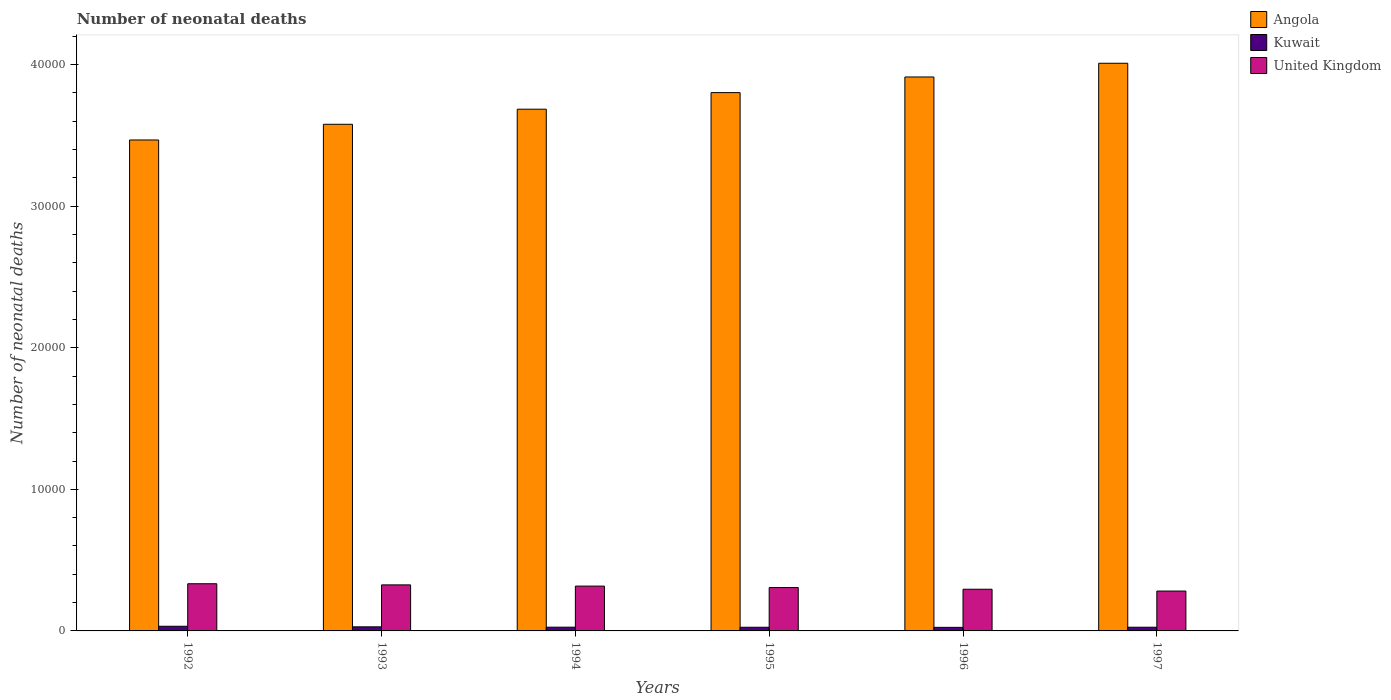How many different coloured bars are there?
Offer a very short reply. 3. How many groups of bars are there?
Keep it short and to the point. 6. How many bars are there on the 1st tick from the left?
Offer a terse response. 3. What is the label of the 4th group of bars from the left?
Offer a terse response. 1995. In how many cases, is the number of bars for a given year not equal to the number of legend labels?
Your response must be concise. 0. What is the number of neonatal deaths in in Angola in 1993?
Keep it short and to the point. 3.58e+04. Across all years, what is the maximum number of neonatal deaths in in Kuwait?
Offer a terse response. 329. Across all years, what is the minimum number of neonatal deaths in in Kuwait?
Offer a terse response. 252. In which year was the number of neonatal deaths in in United Kingdom maximum?
Your answer should be very brief. 1992. What is the total number of neonatal deaths in in Kuwait in the graph?
Your answer should be compact. 1653. What is the difference between the number of neonatal deaths in in Kuwait in 1992 and that in 1996?
Give a very brief answer. 77. What is the difference between the number of neonatal deaths in in United Kingdom in 1992 and the number of neonatal deaths in in Angola in 1993?
Keep it short and to the point. -3.24e+04. What is the average number of neonatal deaths in in Angola per year?
Keep it short and to the point. 3.74e+04. In the year 1993, what is the difference between the number of neonatal deaths in in Kuwait and number of neonatal deaths in in United Kingdom?
Your response must be concise. -2964. In how many years, is the number of neonatal deaths in in Angola greater than 6000?
Your answer should be very brief. 6. What is the ratio of the number of neonatal deaths in in Kuwait in 1995 to that in 1997?
Give a very brief answer. 0.99. What is the difference between the highest and the lowest number of neonatal deaths in in Kuwait?
Your response must be concise. 77. In how many years, is the number of neonatal deaths in in Angola greater than the average number of neonatal deaths in in Angola taken over all years?
Give a very brief answer. 3. Is the sum of the number of neonatal deaths in in Angola in 1994 and 1997 greater than the maximum number of neonatal deaths in in United Kingdom across all years?
Provide a succinct answer. Yes. What does the 2nd bar from the right in 1997 represents?
Your response must be concise. Kuwait. How many bars are there?
Make the answer very short. 18. Are all the bars in the graph horizontal?
Provide a short and direct response. No. How many years are there in the graph?
Provide a succinct answer. 6. What is the difference between two consecutive major ticks on the Y-axis?
Make the answer very short. 10000. Are the values on the major ticks of Y-axis written in scientific E-notation?
Make the answer very short. No. Does the graph contain grids?
Ensure brevity in your answer.  No. Where does the legend appear in the graph?
Make the answer very short. Top right. How are the legend labels stacked?
Keep it short and to the point. Vertical. What is the title of the graph?
Give a very brief answer. Number of neonatal deaths. Does "Togo" appear as one of the legend labels in the graph?
Provide a short and direct response. No. What is the label or title of the Y-axis?
Provide a short and direct response. Number of neonatal deaths. What is the Number of neonatal deaths of Angola in 1992?
Ensure brevity in your answer.  3.47e+04. What is the Number of neonatal deaths of Kuwait in 1992?
Your answer should be compact. 329. What is the Number of neonatal deaths in United Kingdom in 1992?
Your response must be concise. 3332. What is the Number of neonatal deaths of Angola in 1993?
Your response must be concise. 3.58e+04. What is the Number of neonatal deaths in Kuwait in 1993?
Make the answer very short. 288. What is the Number of neonatal deaths of United Kingdom in 1993?
Your answer should be very brief. 3252. What is the Number of neonatal deaths of Angola in 1994?
Give a very brief answer. 3.68e+04. What is the Number of neonatal deaths of Kuwait in 1994?
Your answer should be compact. 264. What is the Number of neonatal deaths in United Kingdom in 1994?
Offer a terse response. 3165. What is the Number of neonatal deaths in Angola in 1995?
Give a very brief answer. 3.80e+04. What is the Number of neonatal deaths of Kuwait in 1995?
Make the answer very short. 259. What is the Number of neonatal deaths of United Kingdom in 1995?
Your answer should be compact. 3063. What is the Number of neonatal deaths of Angola in 1996?
Your response must be concise. 3.91e+04. What is the Number of neonatal deaths in Kuwait in 1996?
Provide a succinct answer. 252. What is the Number of neonatal deaths in United Kingdom in 1996?
Ensure brevity in your answer.  2944. What is the Number of neonatal deaths of Angola in 1997?
Give a very brief answer. 4.01e+04. What is the Number of neonatal deaths in Kuwait in 1997?
Offer a very short reply. 261. What is the Number of neonatal deaths in United Kingdom in 1997?
Make the answer very short. 2816. Across all years, what is the maximum Number of neonatal deaths in Angola?
Your answer should be very brief. 4.01e+04. Across all years, what is the maximum Number of neonatal deaths in Kuwait?
Provide a succinct answer. 329. Across all years, what is the maximum Number of neonatal deaths of United Kingdom?
Your answer should be very brief. 3332. Across all years, what is the minimum Number of neonatal deaths in Angola?
Ensure brevity in your answer.  3.47e+04. Across all years, what is the minimum Number of neonatal deaths in Kuwait?
Offer a very short reply. 252. Across all years, what is the minimum Number of neonatal deaths of United Kingdom?
Keep it short and to the point. 2816. What is the total Number of neonatal deaths of Angola in the graph?
Provide a short and direct response. 2.25e+05. What is the total Number of neonatal deaths of Kuwait in the graph?
Make the answer very short. 1653. What is the total Number of neonatal deaths in United Kingdom in the graph?
Your answer should be very brief. 1.86e+04. What is the difference between the Number of neonatal deaths of Angola in 1992 and that in 1993?
Make the answer very short. -1108. What is the difference between the Number of neonatal deaths of Kuwait in 1992 and that in 1993?
Your response must be concise. 41. What is the difference between the Number of neonatal deaths of Angola in 1992 and that in 1994?
Offer a very short reply. -2175. What is the difference between the Number of neonatal deaths in United Kingdom in 1992 and that in 1994?
Keep it short and to the point. 167. What is the difference between the Number of neonatal deaths of Angola in 1992 and that in 1995?
Your answer should be very brief. -3345. What is the difference between the Number of neonatal deaths in Kuwait in 1992 and that in 1995?
Ensure brevity in your answer.  70. What is the difference between the Number of neonatal deaths of United Kingdom in 1992 and that in 1995?
Provide a short and direct response. 269. What is the difference between the Number of neonatal deaths of Angola in 1992 and that in 1996?
Your answer should be compact. -4450. What is the difference between the Number of neonatal deaths of United Kingdom in 1992 and that in 1996?
Offer a terse response. 388. What is the difference between the Number of neonatal deaths in Angola in 1992 and that in 1997?
Your answer should be compact. -5419. What is the difference between the Number of neonatal deaths in United Kingdom in 1992 and that in 1997?
Your response must be concise. 516. What is the difference between the Number of neonatal deaths of Angola in 1993 and that in 1994?
Offer a terse response. -1067. What is the difference between the Number of neonatal deaths of Kuwait in 1993 and that in 1994?
Give a very brief answer. 24. What is the difference between the Number of neonatal deaths in Angola in 1993 and that in 1995?
Make the answer very short. -2237. What is the difference between the Number of neonatal deaths of United Kingdom in 1993 and that in 1995?
Give a very brief answer. 189. What is the difference between the Number of neonatal deaths of Angola in 1993 and that in 1996?
Offer a very short reply. -3342. What is the difference between the Number of neonatal deaths in Kuwait in 1993 and that in 1996?
Ensure brevity in your answer.  36. What is the difference between the Number of neonatal deaths in United Kingdom in 1993 and that in 1996?
Offer a terse response. 308. What is the difference between the Number of neonatal deaths of Angola in 1993 and that in 1997?
Make the answer very short. -4311. What is the difference between the Number of neonatal deaths in Kuwait in 1993 and that in 1997?
Ensure brevity in your answer.  27. What is the difference between the Number of neonatal deaths in United Kingdom in 1993 and that in 1997?
Ensure brevity in your answer.  436. What is the difference between the Number of neonatal deaths in Angola in 1994 and that in 1995?
Give a very brief answer. -1170. What is the difference between the Number of neonatal deaths in United Kingdom in 1994 and that in 1995?
Offer a terse response. 102. What is the difference between the Number of neonatal deaths in Angola in 1994 and that in 1996?
Your response must be concise. -2275. What is the difference between the Number of neonatal deaths of United Kingdom in 1994 and that in 1996?
Provide a succinct answer. 221. What is the difference between the Number of neonatal deaths of Angola in 1994 and that in 1997?
Give a very brief answer. -3244. What is the difference between the Number of neonatal deaths of United Kingdom in 1994 and that in 1997?
Ensure brevity in your answer.  349. What is the difference between the Number of neonatal deaths in Angola in 1995 and that in 1996?
Offer a very short reply. -1105. What is the difference between the Number of neonatal deaths of Kuwait in 1995 and that in 1996?
Give a very brief answer. 7. What is the difference between the Number of neonatal deaths of United Kingdom in 1995 and that in 1996?
Ensure brevity in your answer.  119. What is the difference between the Number of neonatal deaths of Angola in 1995 and that in 1997?
Your response must be concise. -2074. What is the difference between the Number of neonatal deaths of United Kingdom in 1995 and that in 1997?
Your response must be concise. 247. What is the difference between the Number of neonatal deaths of Angola in 1996 and that in 1997?
Provide a succinct answer. -969. What is the difference between the Number of neonatal deaths in Kuwait in 1996 and that in 1997?
Ensure brevity in your answer.  -9. What is the difference between the Number of neonatal deaths in United Kingdom in 1996 and that in 1997?
Make the answer very short. 128. What is the difference between the Number of neonatal deaths in Angola in 1992 and the Number of neonatal deaths in Kuwait in 1993?
Your answer should be compact. 3.44e+04. What is the difference between the Number of neonatal deaths of Angola in 1992 and the Number of neonatal deaths of United Kingdom in 1993?
Your answer should be compact. 3.14e+04. What is the difference between the Number of neonatal deaths of Kuwait in 1992 and the Number of neonatal deaths of United Kingdom in 1993?
Provide a short and direct response. -2923. What is the difference between the Number of neonatal deaths of Angola in 1992 and the Number of neonatal deaths of Kuwait in 1994?
Provide a succinct answer. 3.44e+04. What is the difference between the Number of neonatal deaths of Angola in 1992 and the Number of neonatal deaths of United Kingdom in 1994?
Provide a short and direct response. 3.15e+04. What is the difference between the Number of neonatal deaths of Kuwait in 1992 and the Number of neonatal deaths of United Kingdom in 1994?
Your answer should be compact. -2836. What is the difference between the Number of neonatal deaths of Angola in 1992 and the Number of neonatal deaths of Kuwait in 1995?
Provide a succinct answer. 3.44e+04. What is the difference between the Number of neonatal deaths in Angola in 1992 and the Number of neonatal deaths in United Kingdom in 1995?
Ensure brevity in your answer.  3.16e+04. What is the difference between the Number of neonatal deaths in Kuwait in 1992 and the Number of neonatal deaths in United Kingdom in 1995?
Provide a succinct answer. -2734. What is the difference between the Number of neonatal deaths of Angola in 1992 and the Number of neonatal deaths of Kuwait in 1996?
Offer a terse response. 3.44e+04. What is the difference between the Number of neonatal deaths in Angola in 1992 and the Number of neonatal deaths in United Kingdom in 1996?
Your response must be concise. 3.17e+04. What is the difference between the Number of neonatal deaths of Kuwait in 1992 and the Number of neonatal deaths of United Kingdom in 1996?
Offer a very short reply. -2615. What is the difference between the Number of neonatal deaths of Angola in 1992 and the Number of neonatal deaths of Kuwait in 1997?
Offer a terse response. 3.44e+04. What is the difference between the Number of neonatal deaths in Angola in 1992 and the Number of neonatal deaths in United Kingdom in 1997?
Keep it short and to the point. 3.19e+04. What is the difference between the Number of neonatal deaths in Kuwait in 1992 and the Number of neonatal deaths in United Kingdom in 1997?
Give a very brief answer. -2487. What is the difference between the Number of neonatal deaths of Angola in 1993 and the Number of neonatal deaths of Kuwait in 1994?
Offer a terse response. 3.55e+04. What is the difference between the Number of neonatal deaths in Angola in 1993 and the Number of neonatal deaths in United Kingdom in 1994?
Provide a short and direct response. 3.26e+04. What is the difference between the Number of neonatal deaths in Kuwait in 1993 and the Number of neonatal deaths in United Kingdom in 1994?
Give a very brief answer. -2877. What is the difference between the Number of neonatal deaths in Angola in 1993 and the Number of neonatal deaths in Kuwait in 1995?
Ensure brevity in your answer.  3.55e+04. What is the difference between the Number of neonatal deaths of Angola in 1993 and the Number of neonatal deaths of United Kingdom in 1995?
Offer a very short reply. 3.27e+04. What is the difference between the Number of neonatal deaths of Kuwait in 1993 and the Number of neonatal deaths of United Kingdom in 1995?
Your answer should be compact. -2775. What is the difference between the Number of neonatal deaths in Angola in 1993 and the Number of neonatal deaths in Kuwait in 1996?
Give a very brief answer. 3.55e+04. What is the difference between the Number of neonatal deaths of Angola in 1993 and the Number of neonatal deaths of United Kingdom in 1996?
Your answer should be very brief. 3.28e+04. What is the difference between the Number of neonatal deaths of Kuwait in 1993 and the Number of neonatal deaths of United Kingdom in 1996?
Your response must be concise. -2656. What is the difference between the Number of neonatal deaths of Angola in 1993 and the Number of neonatal deaths of Kuwait in 1997?
Your answer should be compact. 3.55e+04. What is the difference between the Number of neonatal deaths in Angola in 1993 and the Number of neonatal deaths in United Kingdom in 1997?
Offer a terse response. 3.30e+04. What is the difference between the Number of neonatal deaths of Kuwait in 1993 and the Number of neonatal deaths of United Kingdom in 1997?
Your response must be concise. -2528. What is the difference between the Number of neonatal deaths in Angola in 1994 and the Number of neonatal deaths in Kuwait in 1995?
Your answer should be very brief. 3.66e+04. What is the difference between the Number of neonatal deaths in Angola in 1994 and the Number of neonatal deaths in United Kingdom in 1995?
Keep it short and to the point. 3.38e+04. What is the difference between the Number of neonatal deaths in Kuwait in 1994 and the Number of neonatal deaths in United Kingdom in 1995?
Provide a succinct answer. -2799. What is the difference between the Number of neonatal deaths of Angola in 1994 and the Number of neonatal deaths of Kuwait in 1996?
Provide a short and direct response. 3.66e+04. What is the difference between the Number of neonatal deaths in Angola in 1994 and the Number of neonatal deaths in United Kingdom in 1996?
Ensure brevity in your answer.  3.39e+04. What is the difference between the Number of neonatal deaths of Kuwait in 1994 and the Number of neonatal deaths of United Kingdom in 1996?
Ensure brevity in your answer.  -2680. What is the difference between the Number of neonatal deaths of Angola in 1994 and the Number of neonatal deaths of Kuwait in 1997?
Your answer should be very brief. 3.66e+04. What is the difference between the Number of neonatal deaths of Angola in 1994 and the Number of neonatal deaths of United Kingdom in 1997?
Offer a terse response. 3.40e+04. What is the difference between the Number of neonatal deaths in Kuwait in 1994 and the Number of neonatal deaths in United Kingdom in 1997?
Provide a succinct answer. -2552. What is the difference between the Number of neonatal deaths of Angola in 1995 and the Number of neonatal deaths of Kuwait in 1996?
Your answer should be compact. 3.78e+04. What is the difference between the Number of neonatal deaths in Angola in 1995 and the Number of neonatal deaths in United Kingdom in 1996?
Give a very brief answer. 3.51e+04. What is the difference between the Number of neonatal deaths in Kuwait in 1995 and the Number of neonatal deaths in United Kingdom in 1996?
Offer a terse response. -2685. What is the difference between the Number of neonatal deaths in Angola in 1995 and the Number of neonatal deaths in Kuwait in 1997?
Provide a short and direct response. 3.78e+04. What is the difference between the Number of neonatal deaths in Angola in 1995 and the Number of neonatal deaths in United Kingdom in 1997?
Provide a short and direct response. 3.52e+04. What is the difference between the Number of neonatal deaths of Kuwait in 1995 and the Number of neonatal deaths of United Kingdom in 1997?
Your response must be concise. -2557. What is the difference between the Number of neonatal deaths of Angola in 1996 and the Number of neonatal deaths of Kuwait in 1997?
Your answer should be very brief. 3.89e+04. What is the difference between the Number of neonatal deaths of Angola in 1996 and the Number of neonatal deaths of United Kingdom in 1997?
Provide a short and direct response. 3.63e+04. What is the difference between the Number of neonatal deaths in Kuwait in 1996 and the Number of neonatal deaths in United Kingdom in 1997?
Keep it short and to the point. -2564. What is the average Number of neonatal deaths in Angola per year?
Give a very brief answer. 3.74e+04. What is the average Number of neonatal deaths in Kuwait per year?
Offer a very short reply. 275.5. What is the average Number of neonatal deaths in United Kingdom per year?
Your answer should be very brief. 3095.33. In the year 1992, what is the difference between the Number of neonatal deaths of Angola and Number of neonatal deaths of Kuwait?
Keep it short and to the point. 3.43e+04. In the year 1992, what is the difference between the Number of neonatal deaths in Angola and Number of neonatal deaths in United Kingdom?
Your answer should be compact. 3.13e+04. In the year 1992, what is the difference between the Number of neonatal deaths of Kuwait and Number of neonatal deaths of United Kingdom?
Your response must be concise. -3003. In the year 1993, what is the difference between the Number of neonatal deaths in Angola and Number of neonatal deaths in Kuwait?
Offer a very short reply. 3.55e+04. In the year 1993, what is the difference between the Number of neonatal deaths of Angola and Number of neonatal deaths of United Kingdom?
Provide a short and direct response. 3.25e+04. In the year 1993, what is the difference between the Number of neonatal deaths of Kuwait and Number of neonatal deaths of United Kingdom?
Keep it short and to the point. -2964. In the year 1994, what is the difference between the Number of neonatal deaths in Angola and Number of neonatal deaths in Kuwait?
Make the answer very short. 3.66e+04. In the year 1994, what is the difference between the Number of neonatal deaths in Angola and Number of neonatal deaths in United Kingdom?
Your answer should be compact. 3.37e+04. In the year 1994, what is the difference between the Number of neonatal deaths in Kuwait and Number of neonatal deaths in United Kingdom?
Provide a succinct answer. -2901. In the year 1995, what is the difference between the Number of neonatal deaths in Angola and Number of neonatal deaths in Kuwait?
Provide a short and direct response. 3.78e+04. In the year 1995, what is the difference between the Number of neonatal deaths of Angola and Number of neonatal deaths of United Kingdom?
Provide a short and direct response. 3.50e+04. In the year 1995, what is the difference between the Number of neonatal deaths of Kuwait and Number of neonatal deaths of United Kingdom?
Ensure brevity in your answer.  -2804. In the year 1996, what is the difference between the Number of neonatal deaths in Angola and Number of neonatal deaths in Kuwait?
Offer a terse response. 3.89e+04. In the year 1996, what is the difference between the Number of neonatal deaths in Angola and Number of neonatal deaths in United Kingdom?
Give a very brief answer. 3.62e+04. In the year 1996, what is the difference between the Number of neonatal deaths of Kuwait and Number of neonatal deaths of United Kingdom?
Offer a terse response. -2692. In the year 1997, what is the difference between the Number of neonatal deaths in Angola and Number of neonatal deaths in Kuwait?
Offer a very short reply. 3.98e+04. In the year 1997, what is the difference between the Number of neonatal deaths of Angola and Number of neonatal deaths of United Kingdom?
Offer a terse response. 3.73e+04. In the year 1997, what is the difference between the Number of neonatal deaths in Kuwait and Number of neonatal deaths in United Kingdom?
Keep it short and to the point. -2555. What is the ratio of the Number of neonatal deaths in Angola in 1992 to that in 1993?
Your answer should be very brief. 0.97. What is the ratio of the Number of neonatal deaths of Kuwait in 1992 to that in 1993?
Offer a terse response. 1.14. What is the ratio of the Number of neonatal deaths in United Kingdom in 1992 to that in 1993?
Offer a very short reply. 1.02. What is the ratio of the Number of neonatal deaths of Angola in 1992 to that in 1994?
Offer a terse response. 0.94. What is the ratio of the Number of neonatal deaths of Kuwait in 1992 to that in 1994?
Give a very brief answer. 1.25. What is the ratio of the Number of neonatal deaths of United Kingdom in 1992 to that in 1994?
Make the answer very short. 1.05. What is the ratio of the Number of neonatal deaths in Angola in 1992 to that in 1995?
Your answer should be compact. 0.91. What is the ratio of the Number of neonatal deaths in Kuwait in 1992 to that in 1995?
Make the answer very short. 1.27. What is the ratio of the Number of neonatal deaths of United Kingdom in 1992 to that in 1995?
Your answer should be compact. 1.09. What is the ratio of the Number of neonatal deaths of Angola in 1992 to that in 1996?
Offer a very short reply. 0.89. What is the ratio of the Number of neonatal deaths of Kuwait in 1992 to that in 1996?
Give a very brief answer. 1.31. What is the ratio of the Number of neonatal deaths of United Kingdom in 1992 to that in 1996?
Ensure brevity in your answer.  1.13. What is the ratio of the Number of neonatal deaths of Angola in 1992 to that in 1997?
Your response must be concise. 0.86. What is the ratio of the Number of neonatal deaths in Kuwait in 1992 to that in 1997?
Make the answer very short. 1.26. What is the ratio of the Number of neonatal deaths in United Kingdom in 1992 to that in 1997?
Ensure brevity in your answer.  1.18. What is the ratio of the Number of neonatal deaths in Angola in 1993 to that in 1994?
Your answer should be compact. 0.97. What is the ratio of the Number of neonatal deaths in Kuwait in 1993 to that in 1994?
Give a very brief answer. 1.09. What is the ratio of the Number of neonatal deaths in United Kingdom in 1993 to that in 1994?
Provide a short and direct response. 1.03. What is the ratio of the Number of neonatal deaths in Angola in 1993 to that in 1995?
Offer a terse response. 0.94. What is the ratio of the Number of neonatal deaths of Kuwait in 1993 to that in 1995?
Your response must be concise. 1.11. What is the ratio of the Number of neonatal deaths in United Kingdom in 1993 to that in 1995?
Your answer should be very brief. 1.06. What is the ratio of the Number of neonatal deaths of Angola in 1993 to that in 1996?
Your answer should be very brief. 0.91. What is the ratio of the Number of neonatal deaths of Kuwait in 1993 to that in 1996?
Offer a terse response. 1.14. What is the ratio of the Number of neonatal deaths of United Kingdom in 1993 to that in 1996?
Give a very brief answer. 1.1. What is the ratio of the Number of neonatal deaths of Angola in 1993 to that in 1997?
Keep it short and to the point. 0.89. What is the ratio of the Number of neonatal deaths in Kuwait in 1993 to that in 1997?
Your answer should be compact. 1.1. What is the ratio of the Number of neonatal deaths in United Kingdom in 1993 to that in 1997?
Ensure brevity in your answer.  1.15. What is the ratio of the Number of neonatal deaths in Angola in 1994 to that in 1995?
Provide a short and direct response. 0.97. What is the ratio of the Number of neonatal deaths of Kuwait in 1994 to that in 1995?
Keep it short and to the point. 1.02. What is the ratio of the Number of neonatal deaths in United Kingdom in 1994 to that in 1995?
Give a very brief answer. 1.03. What is the ratio of the Number of neonatal deaths of Angola in 1994 to that in 1996?
Offer a very short reply. 0.94. What is the ratio of the Number of neonatal deaths in Kuwait in 1994 to that in 1996?
Provide a succinct answer. 1.05. What is the ratio of the Number of neonatal deaths of United Kingdom in 1994 to that in 1996?
Offer a very short reply. 1.08. What is the ratio of the Number of neonatal deaths in Angola in 1994 to that in 1997?
Make the answer very short. 0.92. What is the ratio of the Number of neonatal deaths of Kuwait in 1994 to that in 1997?
Your answer should be compact. 1.01. What is the ratio of the Number of neonatal deaths of United Kingdom in 1994 to that in 1997?
Your answer should be compact. 1.12. What is the ratio of the Number of neonatal deaths in Angola in 1995 to that in 1996?
Your response must be concise. 0.97. What is the ratio of the Number of neonatal deaths in Kuwait in 1995 to that in 1996?
Keep it short and to the point. 1.03. What is the ratio of the Number of neonatal deaths of United Kingdom in 1995 to that in 1996?
Offer a very short reply. 1.04. What is the ratio of the Number of neonatal deaths in Angola in 1995 to that in 1997?
Give a very brief answer. 0.95. What is the ratio of the Number of neonatal deaths of United Kingdom in 1995 to that in 1997?
Your answer should be very brief. 1.09. What is the ratio of the Number of neonatal deaths in Angola in 1996 to that in 1997?
Offer a terse response. 0.98. What is the ratio of the Number of neonatal deaths in Kuwait in 1996 to that in 1997?
Your response must be concise. 0.97. What is the ratio of the Number of neonatal deaths in United Kingdom in 1996 to that in 1997?
Ensure brevity in your answer.  1.05. What is the difference between the highest and the second highest Number of neonatal deaths in Angola?
Make the answer very short. 969. What is the difference between the highest and the second highest Number of neonatal deaths of Kuwait?
Provide a short and direct response. 41. What is the difference between the highest and the lowest Number of neonatal deaths of Angola?
Keep it short and to the point. 5419. What is the difference between the highest and the lowest Number of neonatal deaths in United Kingdom?
Offer a terse response. 516. 